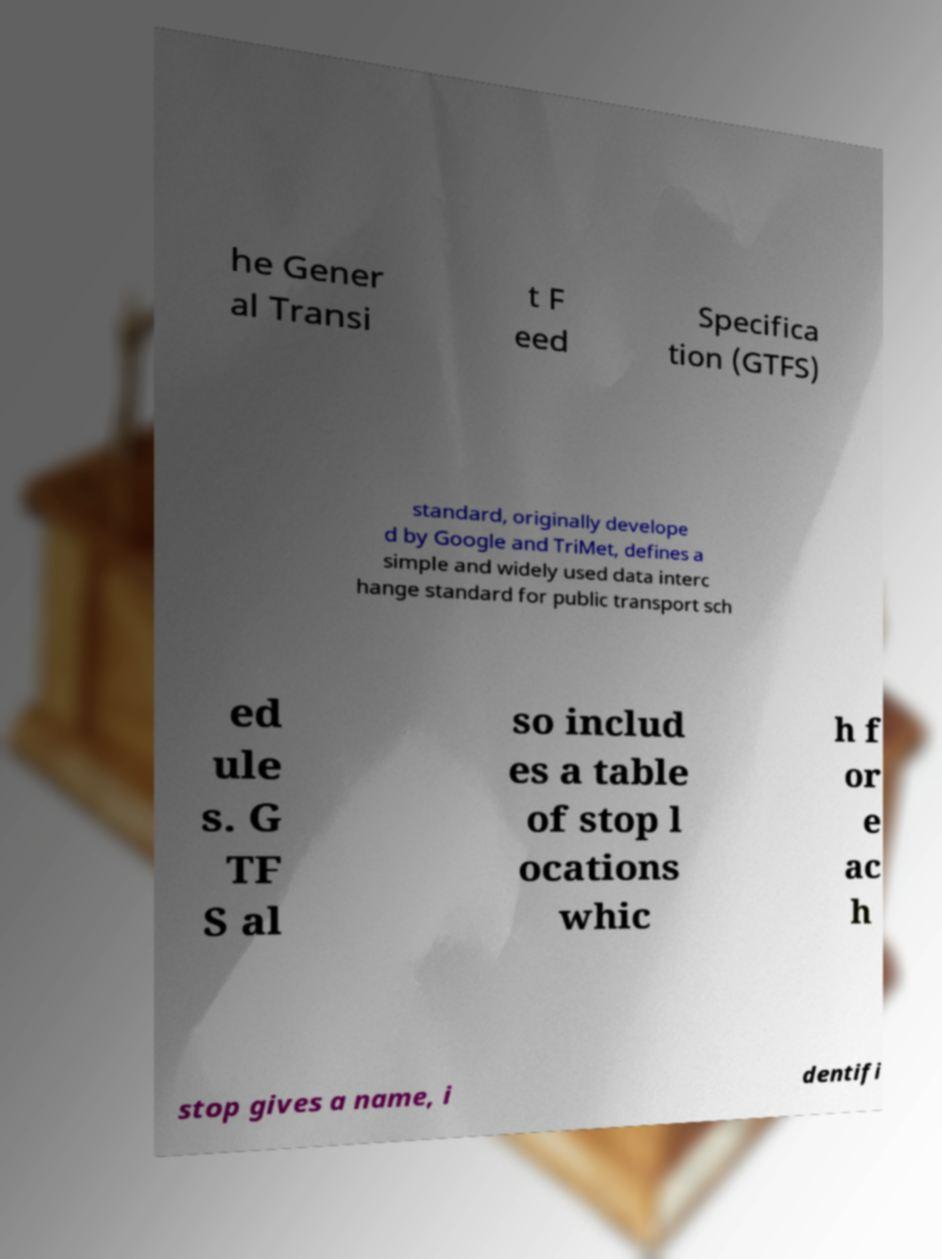There's text embedded in this image that I need extracted. Can you transcribe it verbatim? he Gener al Transi t F eed Specifica tion (GTFS) standard, originally develope d by Google and TriMet, defines a simple and widely used data interc hange standard for public transport sch ed ule s. G TF S al so includ es a table of stop l ocations whic h f or e ac h stop gives a name, i dentifi 